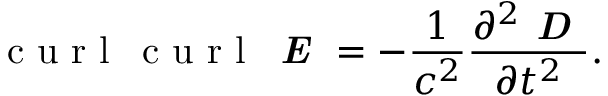<formula> <loc_0><loc_0><loc_500><loc_500>c u r l \, c u r l \, { \em E } = - \frac { 1 } { c ^ { 2 } } \frac { \partial ^ { 2 } { \em D } } { \partial t ^ { 2 } } .</formula> 